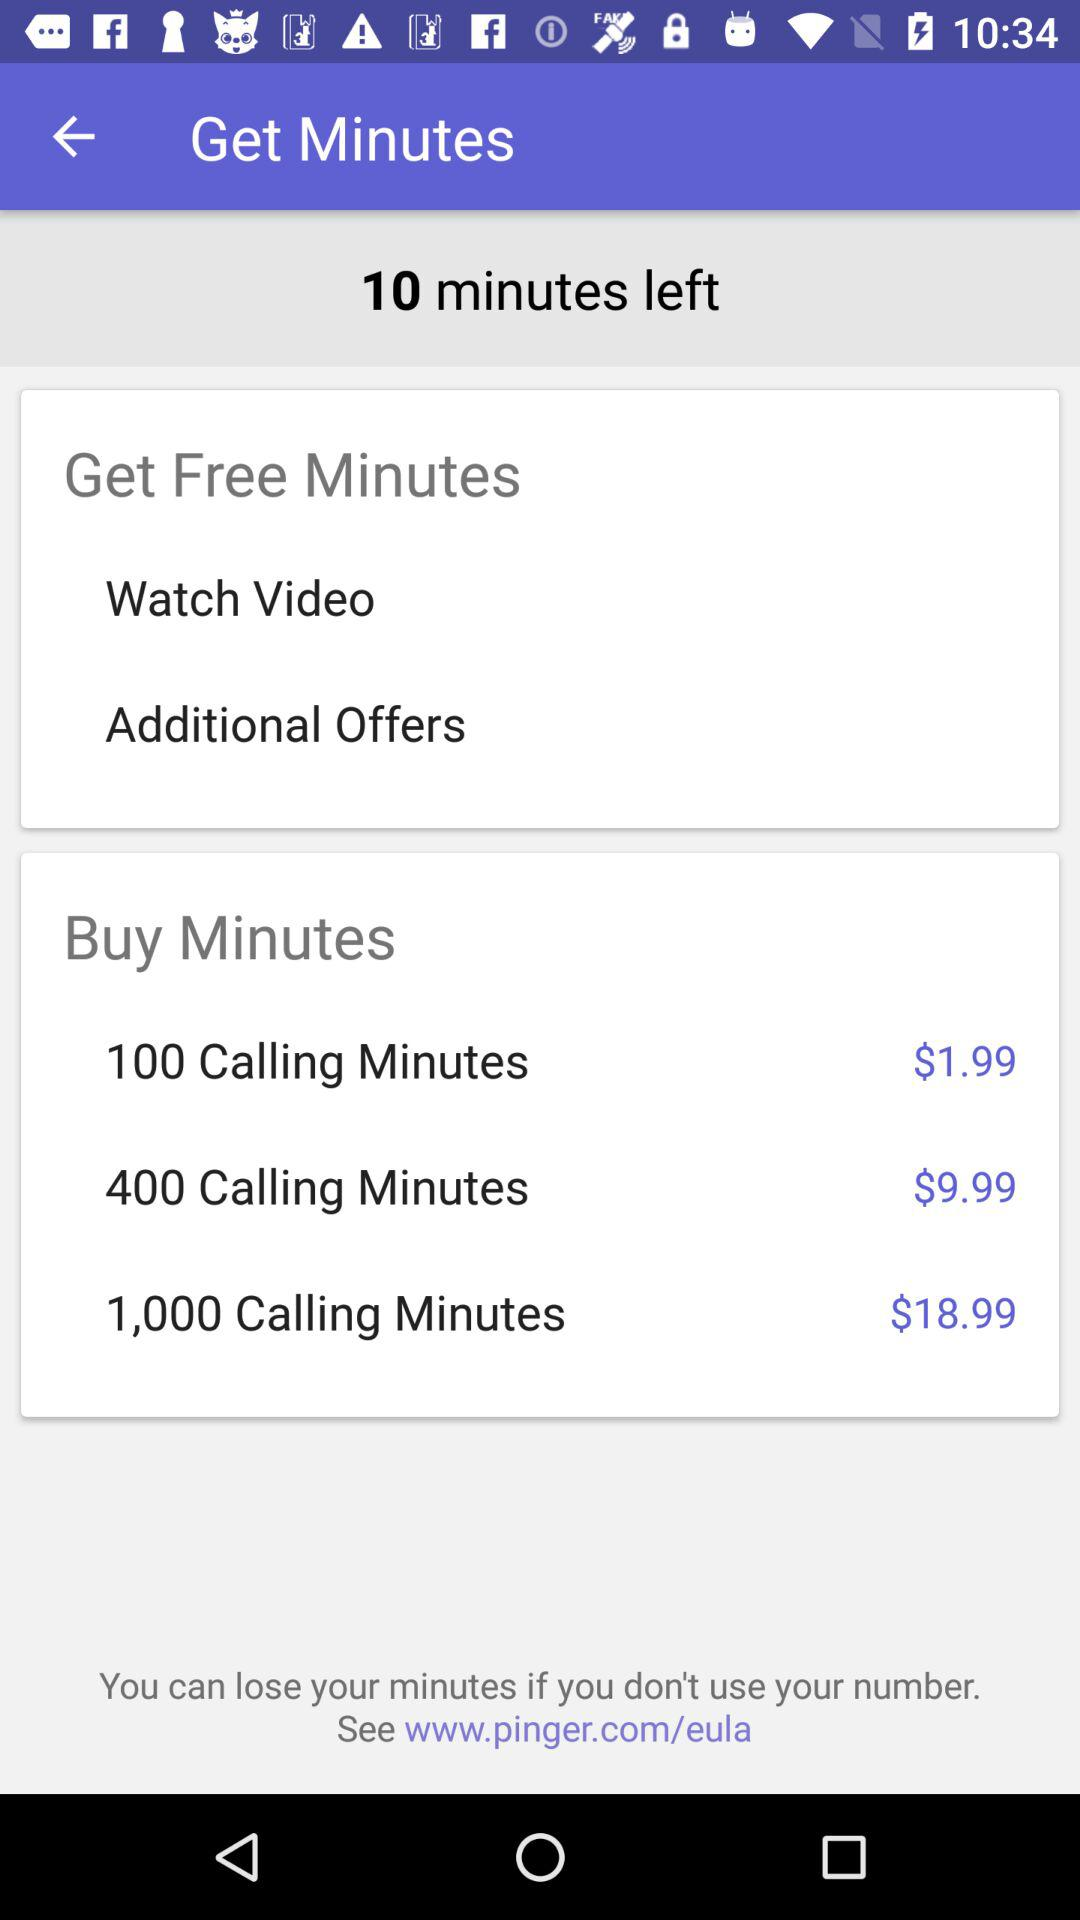What is the price of "1,000 Calling Minutes"? The price of "1,000 Calling Minutes" is $18.99. 